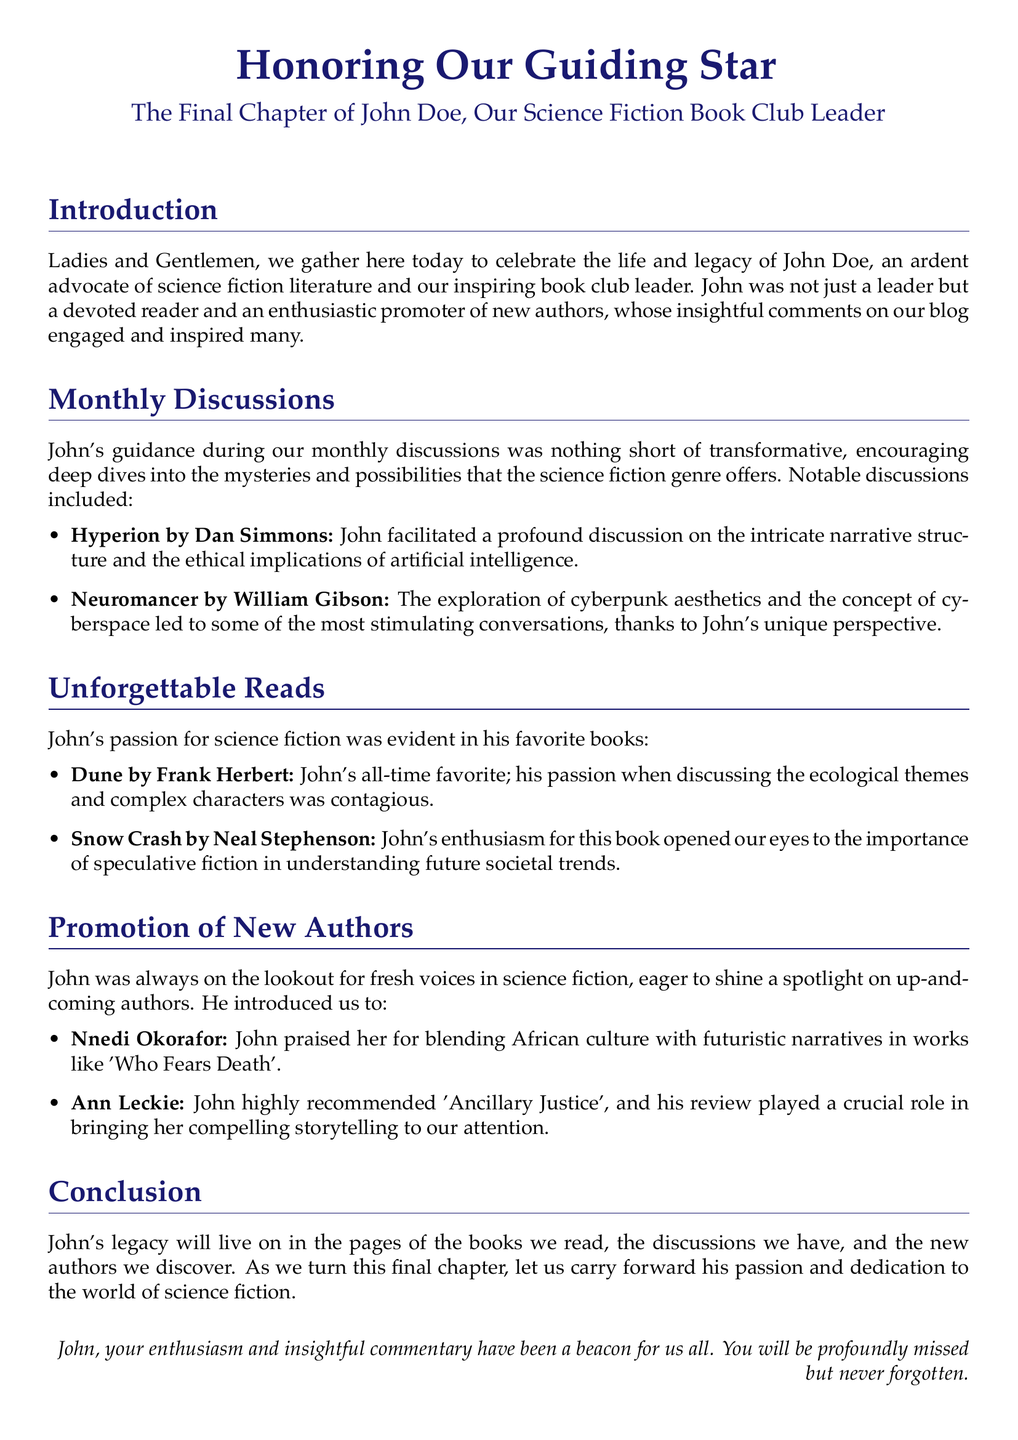What was John Doe's favorite book? The document states that John's all-time favorite book was "Dune."
Answer: Dune Which author did John introduce us to for blending culture with futuristic narratives? The eulogy highlights Nnedi Okorafor for blending African culture with futuristic narratives.
Answer: Nnedi Okorafor What topic did the discussion of "Neuromancer" explore? The document mentions that the exploration of cyberpunk aesthetics and the concept of cyberspace was discussed.
Answer: Cyberpunk aesthetics How frequently were the book discussions held? The eulogy refers to "monthly discussions," indicating the frequency of the meetings.
Answer: Monthly Who wrote "Ancillary Justice"? John highly recommended "Ancillary Justice," and the document notes that it was written by Ann Leckie.
Answer: Ann Leckie What is one notable aspect of the discussion on "Hyperion"? The document states that the discussion included the ethical implications of artificial intelligence.
Answer: Ethical implications of artificial intelligence What will John's legacy live on through? The eulogy indicates that John's legacy will live on in "the pages of the books we read."
Answer: Pages of the books we read What type of literature did John advocate for? The document specifies that John was an advocate of science fiction literature.
Answer: Science fiction literature 